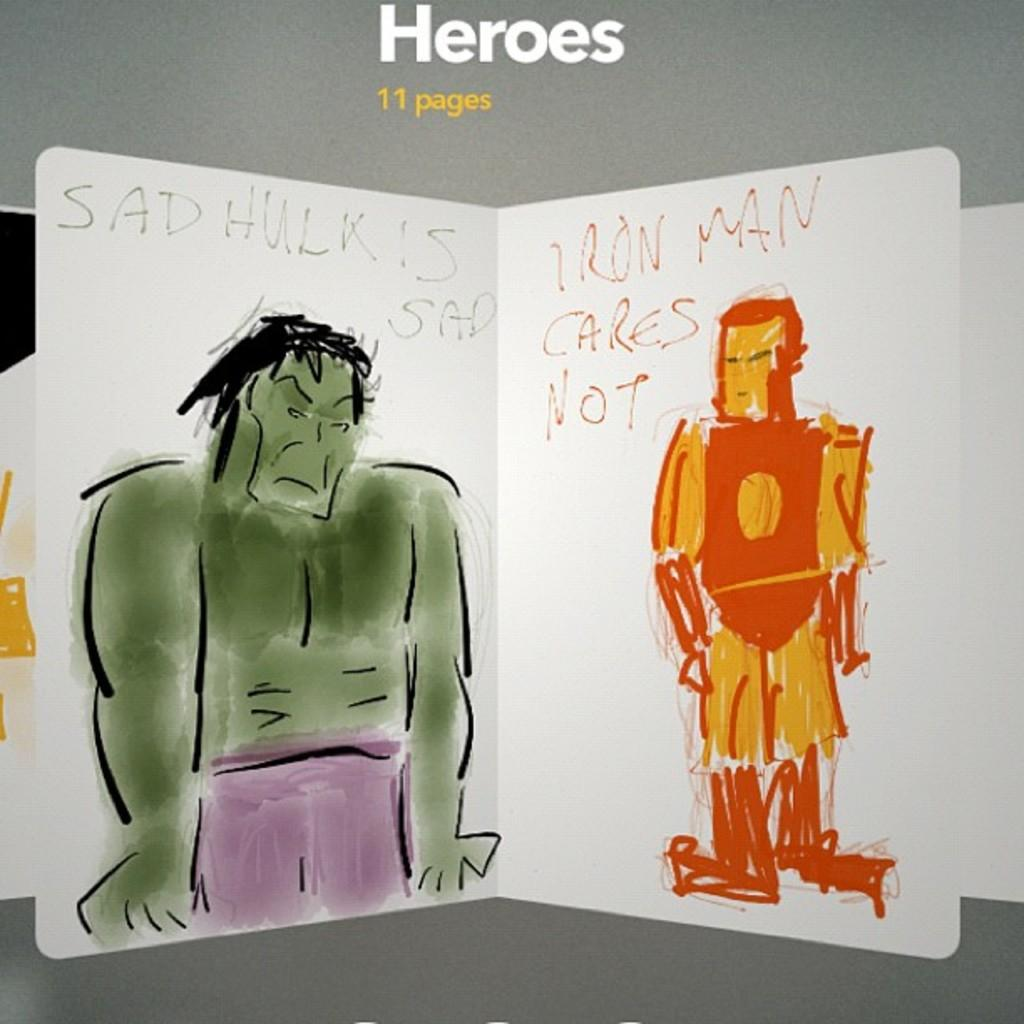What is the main subject of the image? There is a painting in the image. What characters are featured in the painting? The painting features a Hulk and an Iron Man. Is there any text present in the image? Yes, there is some text present in the image. How many bikes can be seen in the painting? There are no bikes present in the painting; it features the Hulk and Iron Man. What type of work is being done in the cemetery in the image? There is no cemetery present in the image; it features a painting with the Hulk and Iron Man. 